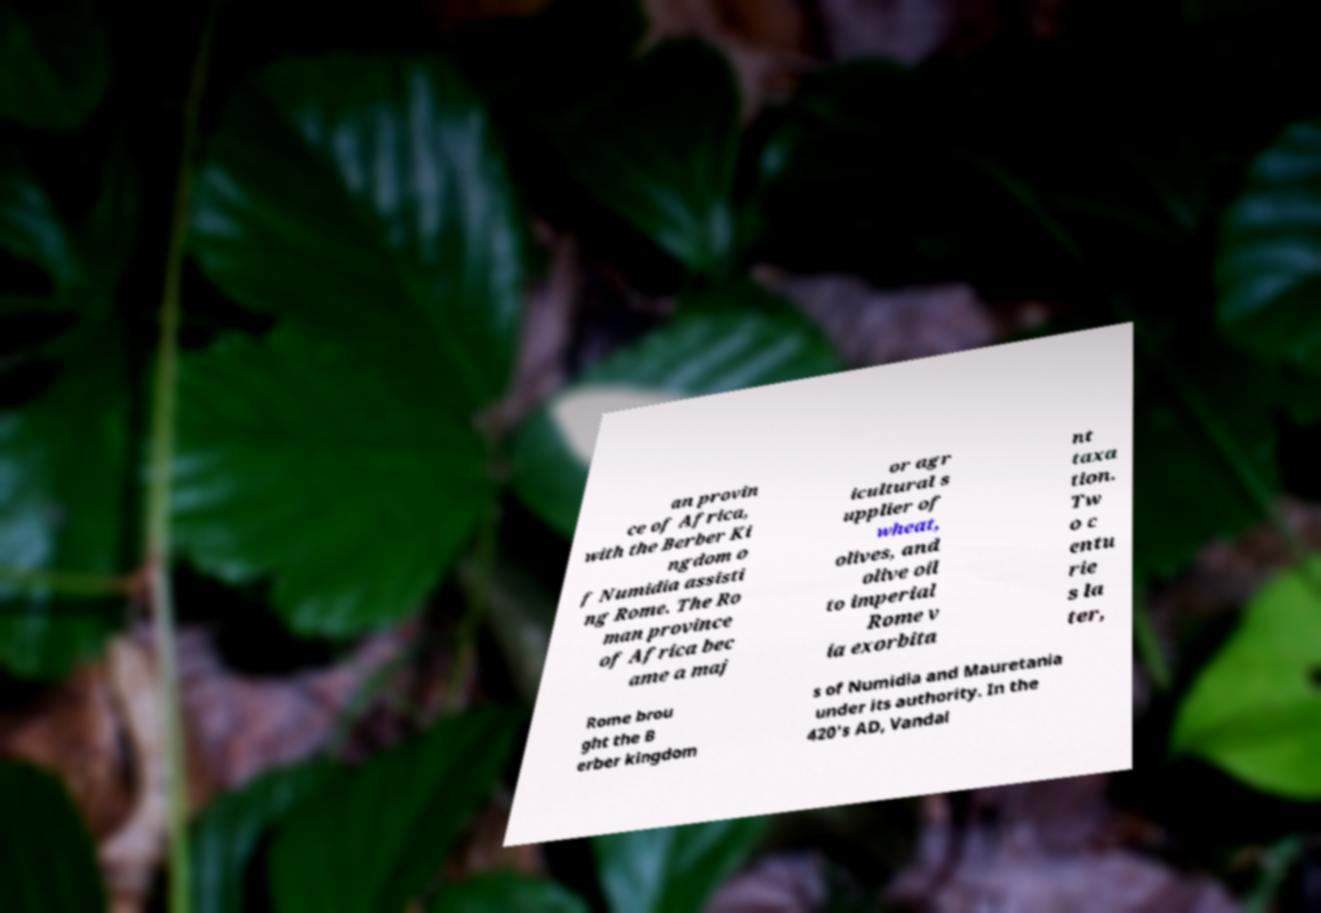I need the written content from this picture converted into text. Can you do that? an provin ce of Africa, with the Berber Ki ngdom o f Numidia assisti ng Rome. The Ro man province of Africa bec ame a maj or agr icultural s upplier of wheat, olives, and olive oil to imperial Rome v ia exorbita nt taxa tion. Tw o c entu rie s la ter, Rome brou ght the B erber kingdom s of Numidia and Mauretania under its authority. In the 420's AD, Vandal 